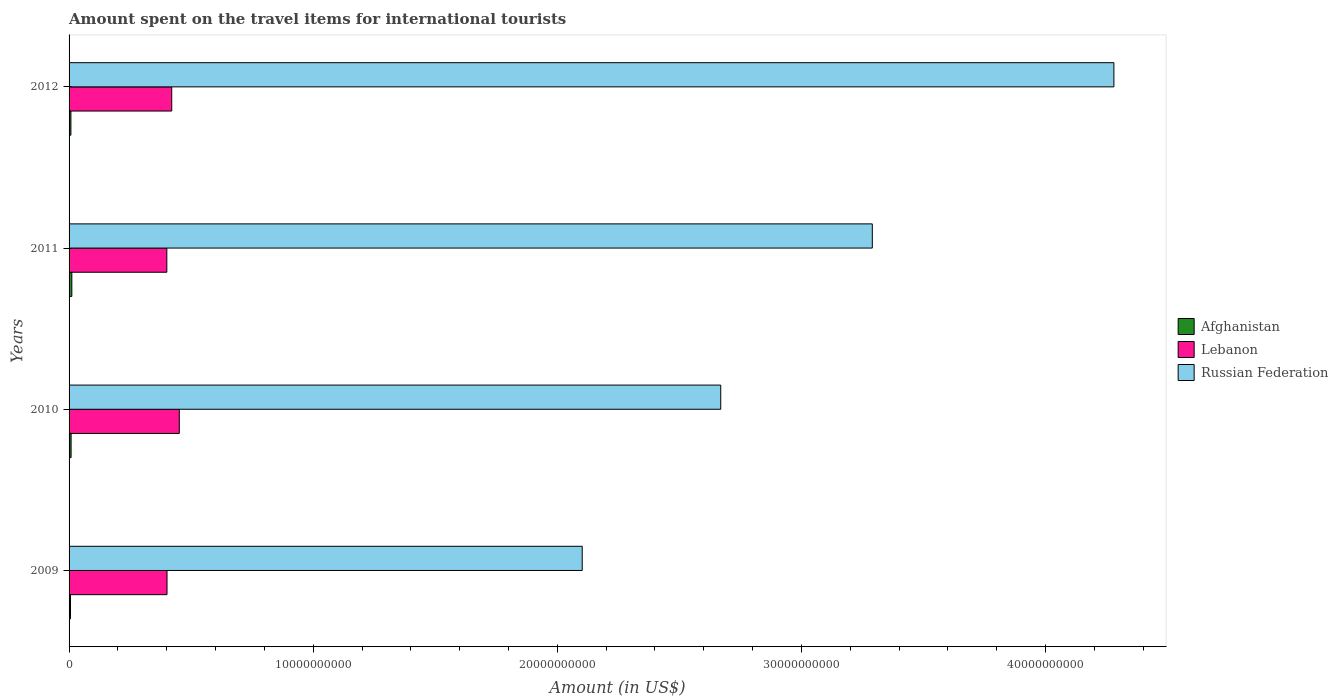How many different coloured bars are there?
Offer a very short reply. 3. How many groups of bars are there?
Make the answer very short. 4. Are the number of bars per tick equal to the number of legend labels?
Your answer should be very brief. Yes. How many bars are there on the 1st tick from the bottom?
Provide a succinct answer. 3. In how many cases, is the number of bars for a given year not equal to the number of legend labels?
Your response must be concise. 0. What is the amount spent on the travel items for international tourists in Russian Federation in 2012?
Offer a terse response. 4.28e+1. Across all years, what is the maximum amount spent on the travel items for international tourists in Afghanistan?
Your answer should be very brief. 1.13e+08. Across all years, what is the minimum amount spent on the travel items for international tourists in Afghanistan?
Keep it short and to the point. 5.90e+07. What is the total amount spent on the travel items for international tourists in Lebanon in the graph?
Offer a very short reply. 1.67e+1. What is the difference between the amount spent on the travel items for international tourists in Afghanistan in 2009 and that in 2011?
Provide a short and direct response. -5.40e+07. What is the difference between the amount spent on the travel items for international tourists in Lebanon in 2010 and the amount spent on the travel items for international tourists in Russian Federation in 2009?
Keep it short and to the point. -1.65e+1. What is the average amount spent on the travel items for international tourists in Afghanistan per year?
Give a very brief answer. 8.25e+07. In the year 2011, what is the difference between the amount spent on the travel items for international tourists in Afghanistan and amount spent on the travel items for international tourists in Russian Federation?
Your answer should be very brief. -3.28e+1. In how many years, is the amount spent on the travel items for international tourists in Afghanistan greater than 42000000000 US$?
Your answer should be very brief. 0. What is the ratio of the amount spent on the travel items for international tourists in Afghanistan in 2009 to that in 2011?
Provide a succinct answer. 0.52. Is the amount spent on the travel items for international tourists in Russian Federation in 2010 less than that in 2011?
Give a very brief answer. Yes. Is the difference between the amount spent on the travel items for international tourists in Afghanistan in 2010 and 2011 greater than the difference between the amount spent on the travel items for international tourists in Russian Federation in 2010 and 2011?
Your response must be concise. Yes. What is the difference between the highest and the second highest amount spent on the travel items for international tourists in Afghanistan?
Your answer should be very brief. 3.00e+07. What is the difference between the highest and the lowest amount spent on the travel items for international tourists in Lebanon?
Offer a very short reply. 5.11e+08. Is the sum of the amount spent on the travel items for international tourists in Lebanon in 2009 and 2012 greater than the maximum amount spent on the travel items for international tourists in Russian Federation across all years?
Give a very brief answer. No. What does the 1st bar from the top in 2010 represents?
Make the answer very short. Russian Federation. What does the 1st bar from the bottom in 2012 represents?
Provide a succinct answer. Afghanistan. How many bars are there?
Provide a succinct answer. 12. How many years are there in the graph?
Your answer should be compact. 4. What is the difference between two consecutive major ticks on the X-axis?
Offer a terse response. 1.00e+1. Does the graph contain any zero values?
Offer a terse response. No. Where does the legend appear in the graph?
Keep it short and to the point. Center right. What is the title of the graph?
Offer a very short reply. Amount spent on the travel items for international tourists. Does "Myanmar" appear as one of the legend labels in the graph?
Provide a succinct answer. No. What is the Amount (in US$) of Afghanistan in 2009?
Provide a short and direct response. 5.90e+07. What is the Amount (in US$) in Lebanon in 2009?
Your answer should be compact. 4.01e+09. What is the Amount (in US$) of Russian Federation in 2009?
Offer a terse response. 2.10e+1. What is the Amount (in US$) of Afghanistan in 2010?
Keep it short and to the point. 8.30e+07. What is the Amount (in US$) of Lebanon in 2010?
Give a very brief answer. 4.52e+09. What is the Amount (in US$) in Russian Federation in 2010?
Your response must be concise. 2.67e+1. What is the Amount (in US$) in Afghanistan in 2011?
Your response must be concise. 1.13e+08. What is the Amount (in US$) of Lebanon in 2011?
Ensure brevity in your answer.  4.00e+09. What is the Amount (in US$) of Russian Federation in 2011?
Keep it short and to the point. 3.29e+1. What is the Amount (in US$) of Afghanistan in 2012?
Make the answer very short. 7.50e+07. What is the Amount (in US$) in Lebanon in 2012?
Give a very brief answer. 4.20e+09. What is the Amount (in US$) in Russian Federation in 2012?
Give a very brief answer. 4.28e+1. Across all years, what is the maximum Amount (in US$) of Afghanistan?
Ensure brevity in your answer.  1.13e+08. Across all years, what is the maximum Amount (in US$) in Lebanon?
Make the answer very short. 4.52e+09. Across all years, what is the maximum Amount (in US$) of Russian Federation?
Your answer should be very brief. 4.28e+1. Across all years, what is the minimum Amount (in US$) in Afghanistan?
Provide a succinct answer. 5.90e+07. Across all years, what is the minimum Amount (in US$) in Lebanon?
Offer a very short reply. 4.00e+09. Across all years, what is the minimum Amount (in US$) in Russian Federation?
Your answer should be compact. 2.10e+1. What is the total Amount (in US$) of Afghanistan in the graph?
Provide a short and direct response. 3.30e+08. What is the total Amount (in US$) in Lebanon in the graph?
Offer a very short reply. 1.67e+1. What is the total Amount (in US$) in Russian Federation in the graph?
Your response must be concise. 1.23e+11. What is the difference between the Amount (in US$) of Afghanistan in 2009 and that in 2010?
Provide a short and direct response. -2.40e+07. What is the difference between the Amount (in US$) of Lebanon in 2009 and that in 2010?
Provide a succinct answer. -5.03e+08. What is the difference between the Amount (in US$) in Russian Federation in 2009 and that in 2010?
Offer a very short reply. -5.67e+09. What is the difference between the Amount (in US$) in Afghanistan in 2009 and that in 2011?
Provide a short and direct response. -5.40e+07. What is the difference between the Amount (in US$) of Lebanon in 2009 and that in 2011?
Provide a succinct answer. 8.00e+06. What is the difference between the Amount (in US$) in Russian Federation in 2009 and that in 2011?
Provide a succinct answer. -1.19e+1. What is the difference between the Amount (in US$) in Afghanistan in 2009 and that in 2012?
Ensure brevity in your answer.  -1.60e+07. What is the difference between the Amount (in US$) in Lebanon in 2009 and that in 2012?
Provide a short and direct response. -1.93e+08. What is the difference between the Amount (in US$) of Russian Federation in 2009 and that in 2012?
Provide a succinct answer. -2.18e+1. What is the difference between the Amount (in US$) of Afghanistan in 2010 and that in 2011?
Provide a short and direct response. -3.00e+07. What is the difference between the Amount (in US$) in Lebanon in 2010 and that in 2011?
Ensure brevity in your answer.  5.11e+08. What is the difference between the Amount (in US$) in Russian Federation in 2010 and that in 2011?
Provide a succinct answer. -6.21e+09. What is the difference between the Amount (in US$) of Lebanon in 2010 and that in 2012?
Give a very brief answer. 3.10e+08. What is the difference between the Amount (in US$) of Russian Federation in 2010 and that in 2012?
Offer a terse response. -1.61e+1. What is the difference between the Amount (in US$) of Afghanistan in 2011 and that in 2012?
Your response must be concise. 3.80e+07. What is the difference between the Amount (in US$) of Lebanon in 2011 and that in 2012?
Your response must be concise. -2.01e+08. What is the difference between the Amount (in US$) in Russian Federation in 2011 and that in 2012?
Provide a short and direct response. -9.90e+09. What is the difference between the Amount (in US$) of Afghanistan in 2009 and the Amount (in US$) of Lebanon in 2010?
Provide a succinct answer. -4.46e+09. What is the difference between the Amount (in US$) in Afghanistan in 2009 and the Amount (in US$) in Russian Federation in 2010?
Make the answer very short. -2.66e+1. What is the difference between the Amount (in US$) of Lebanon in 2009 and the Amount (in US$) of Russian Federation in 2010?
Make the answer very short. -2.27e+1. What is the difference between the Amount (in US$) of Afghanistan in 2009 and the Amount (in US$) of Lebanon in 2011?
Ensure brevity in your answer.  -3.94e+09. What is the difference between the Amount (in US$) of Afghanistan in 2009 and the Amount (in US$) of Russian Federation in 2011?
Keep it short and to the point. -3.28e+1. What is the difference between the Amount (in US$) in Lebanon in 2009 and the Amount (in US$) in Russian Federation in 2011?
Offer a terse response. -2.89e+1. What is the difference between the Amount (in US$) of Afghanistan in 2009 and the Amount (in US$) of Lebanon in 2012?
Provide a short and direct response. -4.15e+09. What is the difference between the Amount (in US$) in Afghanistan in 2009 and the Amount (in US$) in Russian Federation in 2012?
Offer a terse response. -4.27e+1. What is the difference between the Amount (in US$) of Lebanon in 2009 and the Amount (in US$) of Russian Federation in 2012?
Give a very brief answer. -3.88e+1. What is the difference between the Amount (in US$) of Afghanistan in 2010 and the Amount (in US$) of Lebanon in 2011?
Your response must be concise. -3.92e+09. What is the difference between the Amount (in US$) in Afghanistan in 2010 and the Amount (in US$) in Russian Federation in 2011?
Your answer should be very brief. -3.28e+1. What is the difference between the Amount (in US$) in Lebanon in 2010 and the Amount (in US$) in Russian Federation in 2011?
Your answer should be compact. -2.84e+1. What is the difference between the Amount (in US$) of Afghanistan in 2010 and the Amount (in US$) of Lebanon in 2012?
Make the answer very short. -4.12e+09. What is the difference between the Amount (in US$) of Afghanistan in 2010 and the Amount (in US$) of Russian Federation in 2012?
Provide a short and direct response. -4.27e+1. What is the difference between the Amount (in US$) of Lebanon in 2010 and the Amount (in US$) of Russian Federation in 2012?
Ensure brevity in your answer.  -3.83e+1. What is the difference between the Amount (in US$) of Afghanistan in 2011 and the Amount (in US$) of Lebanon in 2012?
Offer a terse response. -4.09e+09. What is the difference between the Amount (in US$) of Afghanistan in 2011 and the Amount (in US$) of Russian Federation in 2012?
Your answer should be compact. -4.27e+1. What is the difference between the Amount (in US$) of Lebanon in 2011 and the Amount (in US$) of Russian Federation in 2012?
Your answer should be very brief. -3.88e+1. What is the average Amount (in US$) of Afghanistan per year?
Your response must be concise. 8.25e+07. What is the average Amount (in US$) in Lebanon per year?
Offer a very short reply. 4.18e+09. What is the average Amount (in US$) in Russian Federation per year?
Offer a terse response. 3.09e+1. In the year 2009, what is the difference between the Amount (in US$) in Afghanistan and Amount (in US$) in Lebanon?
Give a very brief answer. -3.95e+09. In the year 2009, what is the difference between the Amount (in US$) in Afghanistan and Amount (in US$) in Russian Federation?
Offer a very short reply. -2.10e+1. In the year 2009, what is the difference between the Amount (in US$) in Lebanon and Amount (in US$) in Russian Federation?
Offer a terse response. -1.70e+1. In the year 2010, what is the difference between the Amount (in US$) of Afghanistan and Amount (in US$) of Lebanon?
Your answer should be compact. -4.43e+09. In the year 2010, what is the difference between the Amount (in US$) in Afghanistan and Amount (in US$) in Russian Federation?
Your answer should be very brief. -2.66e+1. In the year 2010, what is the difference between the Amount (in US$) of Lebanon and Amount (in US$) of Russian Federation?
Keep it short and to the point. -2.22e+1. In the year 2011, what is the difference between the Amount (in US$) in Afghanistan and Amount (in US$) in Lebanon?
Keep it short and to the point. -3.89e+09. In the year 2011, what is the difference between the Amount (in US$) of Afghanistan and Amount (in US$) of Russian Federation?
Offer a terse response. -3.28e+1. In the year 2011, what is the difference between the Amount (in US$) of Lebanon and Amount (in US$) of Russian Federation?
Offer a very short reply. -2.89e+1. In the year 2012, what is the difference between the Amount (in US$) in Afghanistan and Amount (in US$) in Lebanon?
Your answer should be compact. -4.13e+09. In the year 2012, what is the difference between the Amount (in US$) of Afghanistan and Amount (in US$) of Russian Federation?
Your answer should be very brief. -4.27e+1. In the year 2012, what is the difference between the Amount (in US$) in Lebanon and Amount (in US$) in Russian Federation?
Provide a succinct answer. -3.86e+1. What is the ratio of the Amount (in US$) in Afghanistan in 2009 to that in 2010?
Provide a succinct answer. 0.71. What is the ratio of the Amount (in US$) of Lebanon in 2009 to that in 2010?
Keep it short and to the point. 0.89. What is the ratio of the Amount (in US$) of Russian Federation in 2009 to that in 2010?
Ensure brevity in your answer.  0.79. What is the ratio of the Amount (in US$) of Afghanistan in 2009 to that in 2011?
Offer a terse response. 0.52. What is the ratio of the Amount (in US$) of Russian Federation in 2009 to that in 2011?
Give a very brief answer. 0.64. What is the ratio of the Amount (in US$) in Afghanistan in 2009 to that in 2012?
Ensure brevity in your answer.  0.79. What is the ratio of the Amount (in US$) in Lebanon in 2009 to that in 2012?
Your answer should be compact. 0.95. What is the ratio of the Amount (in US$) of Russian Federation in 2009 to that in 2012?
Keep it short and to the point. 0.49. What is the ratio of the Amount (in US$) of Afghanistan in 2010 to that in 2011?
Your answer should be very brief. 0.73. What is the ratio of the Amount (in US$) in Lebanon in 2010 to that in 2011?
Keep it short and to the point. 1.13. What is the ratio of the Amount (in US$) of Russian Federation in 2010 to that in 2011?
Provide a short and direct response. 0.81. What is the ratio of the Amount (in US$) of Afghanistan in 2010 to that in 2012?
Offer a terse response. 1.11. What is the ratio of the Amount (in US$) in Lebanon in 2010 to that in 2012?
Ensure brevity in your answer.  1.07. What is the ratio of the Amount (in US$) in Russian Federation in 2010 to that in 2012?
Provide a succinct answer. 0.62. What is the ratio of the Amount (in US$) in Afghanistan in 2011 to that in 2012?
Offer a terse response. 1.51. What is the ratio of the Amount (in US$) of Lebanon in 2011 to that in 2012?
Your response must be concise. 0.95. What is the ratio of the Amount (in US$) of Russian Federation in 2011 to that in 2012?
Provide a short and direct response. 0.77. What is the difference between the highest and the second highest Amount (in US$) in Afghanistan?
Offer a very short reply. 3.00e+07. What is the difference between the highest and the second highest Amount (in US$) in Lebanon?
Provide a succinct answer. 3.10e+08. What is the difference between the highest and the second highest Amount (in US$) in Russian Federation?
Make the answer very short. 9.90e+09. What is the difference between the highest and the lowest Amount (in US$) in Afghanistan?
Offer a terse response. 5.40e+07. What is the difference between the highest and the lowest Amount (in US$) in Lebanon?
Your response must be concise. 5.11e+08. What is the difference between the highest and the lowest Amount (in US$) of Russian Federation?
Keep it short and to the point. 2.18e+1. 